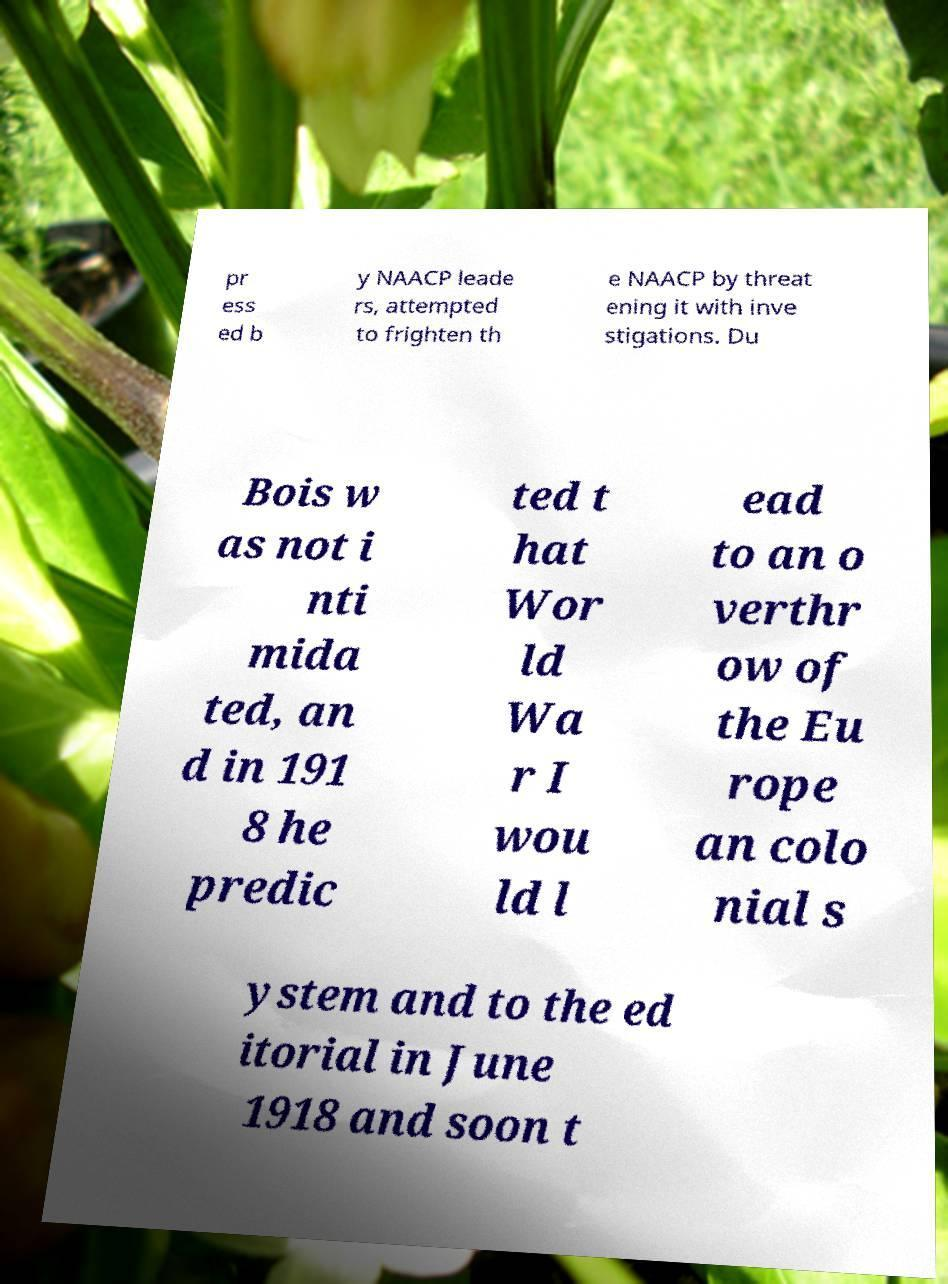What messages or text are displayed in this image? I need them in a readable, typed format. pr ess ed b y NAACP leade rs, attempted to frighten th e NAACP by threat ening it with inve stigations. Du Bois w as not i nti mida ted, an d in 191 8 he predic ted t hat Wor ld Wa r I wou ld l ead to an o verthr ow of the Eu rope an colo nial s ystem and to the ed itorial in June 1918 and soon t 